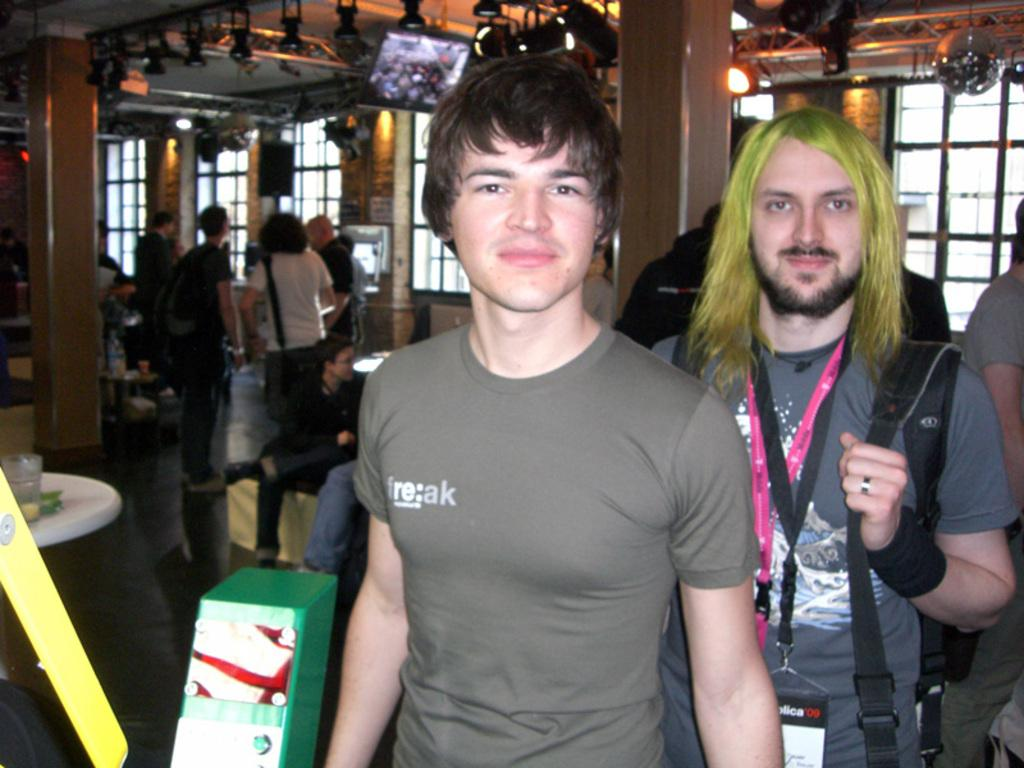What are the people in the image doing? There are people standing and sitting in the image. What architectural features can be seen in the image? There are pillars in the image. What can be seen through the windows in the image? The presence of windows suggests that there is a view outside, but the specifics are not mentioned in the facts. What type of lighting is present in the image? There are lights in the image. What electronic devices are visible in the image? There are screens in the image. What objects can be found on the tables in the image? The presence of objects on the tables is mentioned, but their specifics are not provided in the facts. What type of cast can be seen fishing at the harbor in the image? There is no cast or harbor present in the image; it features people standing and sitting, pillars, windows, lights, screens, and objects on tables. 